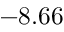<formula> <loc_0><loc_0><loc_500><loc_500>- 8 . 6 6</formula> 